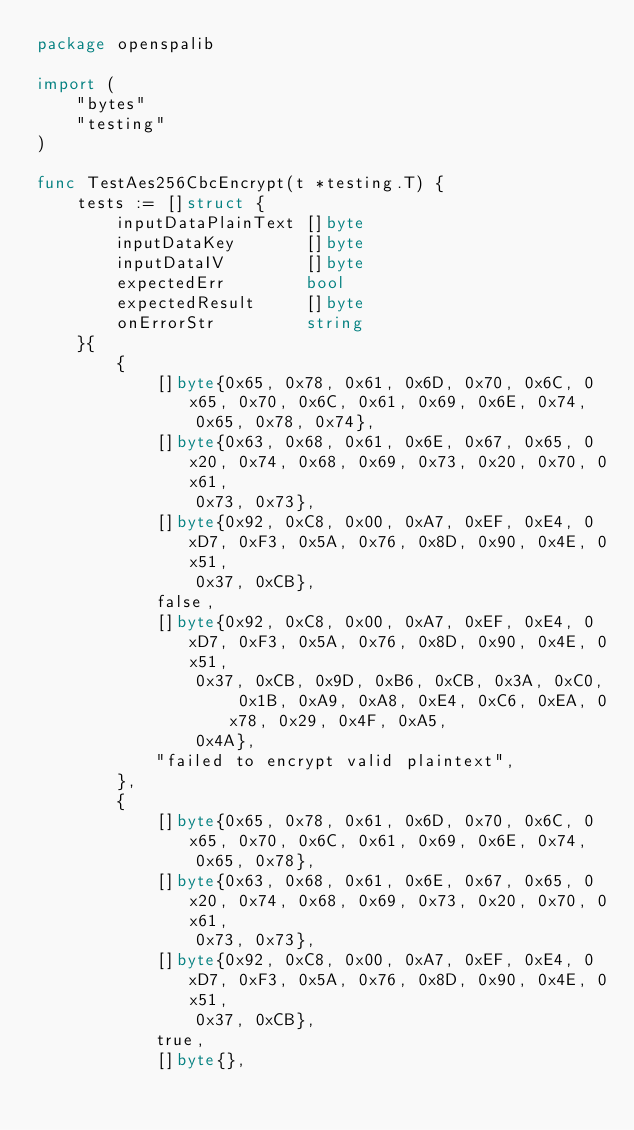Convert code to text. <code><loc_0><loc_0><loc_500><loc_500><_Go_>package openspalib

import (
	"bytes"
	"testing"
)

func TestAes256CbcEncrypt(t *testing.T) {
	tests := []struct {
		inputDataPlainText []byte
		inputDataKey       []byte
		inputDataIV        []byte
		expectedErr        bool
		expectedResult     []byte
		onErrorStr         string
	}{
		{
			[]byte{0x65, 0x78, 0x61, 0x6D, 0x70, 0x6C, 0x65, 0x70, 0x6C, 0x61, 0x69, 0x6E, 0x74,
				0x65, 0x78, 0x74},
			[]byte{0x63, 0x68, 0x61, 0x6E, 0x67, 0x65, 0x20, 0x74, 0x68, 0x69, 0x73, 0x20, 0x70, 0x61,
				0x73, 0x73},
			[]byte{0x92, 0xC8, 0x00, 0xA7, 0xEF, 0xE4, 0xD7, 0xF3, 0x5A, 0x76, 0x8D, 0x90, 0x4E, 0x51,
				0x37, 0xCB},
			false,
			[]byte{0x92, 0xC8, 0x00, 0xA7, 0xEF, 0xE4, 0xD7, 0xF3, 0x5A, 0x76, 0x8D, 0x90, 0x4E, 0x51,
				0x37, 0xCB, 0x9D, 0xB6, 0xCB, 0x3A, 0xC0, 0x1B, 0xA9, 0xA8, 0xE4, 0xC6, 0xEA, 0x78, 0x29, 0x4F, 0xA5,
				0x4A},
			"failed to encrypt valid plaintext",
		},
		{
			[]byte{0x65, 0x78, 0x61, 0x6D, 0x70, 0x6C, 0x65, 0x70, 0x6C, 0x61, 0x69, 0x6E, 0x74,
				0x65, 0x78},
			[]byte{0x63, 0x68, 0x61, 0x6E, 0x67, 0x65, 0x20, 0x74, 0x68, 0x69, 0x73, 0x20, 0x70, 0x61,
				0x73, 0x73},
			[]byte{0x92, 0xC8, 0x00, 0xA7, 0xEF, 0xE4, 0xD7, 0xF3, 0x5A, 0x76, 0x8D, 0x90, 0x4E, 0x51,
				0x37, 0xCB},
			true,
			[]byte{},</code> 